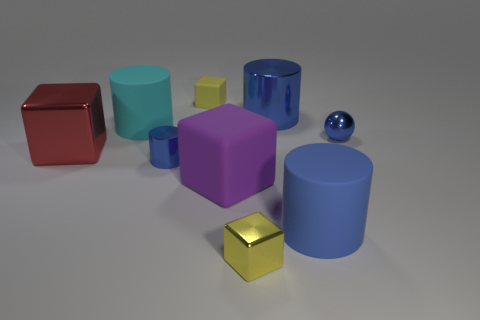What number of yellow metal blocks are on the left side of the small blue thing on the left side of the small blue shiny object behind the large red metallic cube?
Make the answer very short. 0. How many blue shiny objects are to the right of the big purple matte object and in front of the tiny blue sphere?
Provide a succinct answer. 0. What is the shape of the small thing that is the same color as the metal ball?
Give a very brief answer. Cylinder. Is there any other thing that has the same material as the small ball?
Keep it short and to the point. Yes. Does the tiny ball have the same material as the red thing?
Offer a terse response. Yes. What shape is the tiny blue shiny thing on the left side of the rubber cylinder that is right of the small yellow object in front of the tiny blue metal cylinder?
Make the answer very short. Cylinder. Are there fewer large blue cylinders in front of the purple object than big cylinders that are in front of the large blue metallic cylinder?
Offer a very short reply. Yes. There is a metallic thing right of the big blue cylinder in front of the large rubber block; what is its shape?
Provide a short and direct response. Sphere. Is there anything else that has the same color as the small metallic cylinder?
Your answer should be very brief. Yes. Is the tiny matte object the same color as the small shiny cube?
Keep it short and to the point. Yes. 